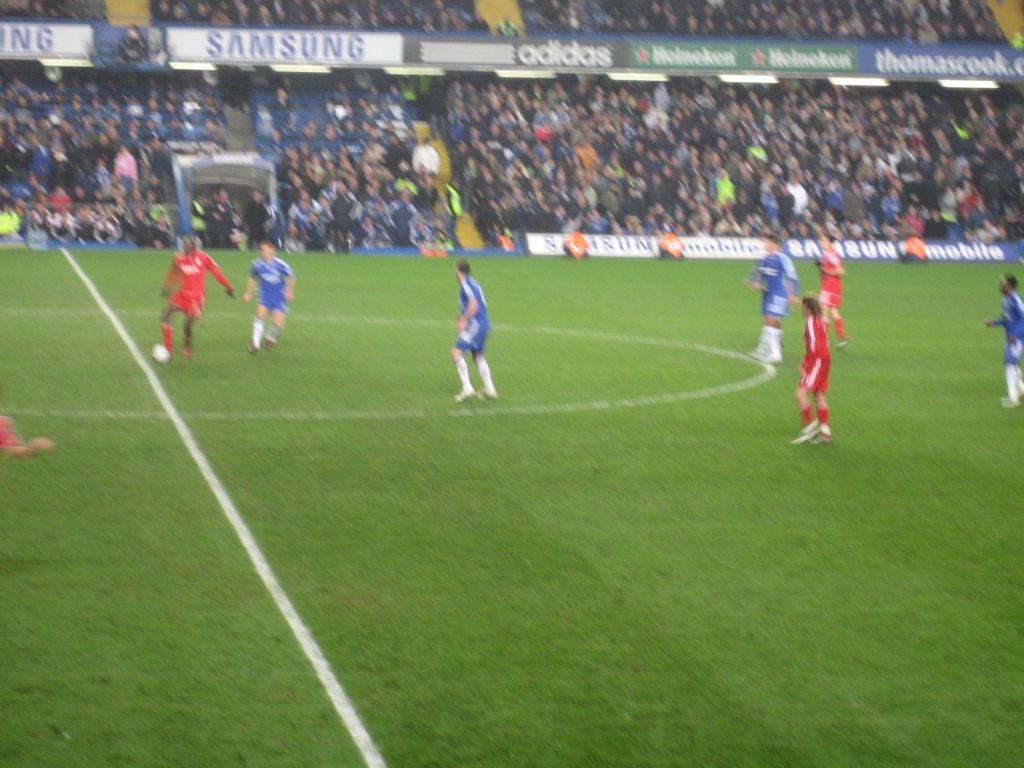Which companies have sponsored the sporting event?
Keep it short and to the point. Samsung. What beer company is a sponsor?
Give a very brief answer. Heineken. 